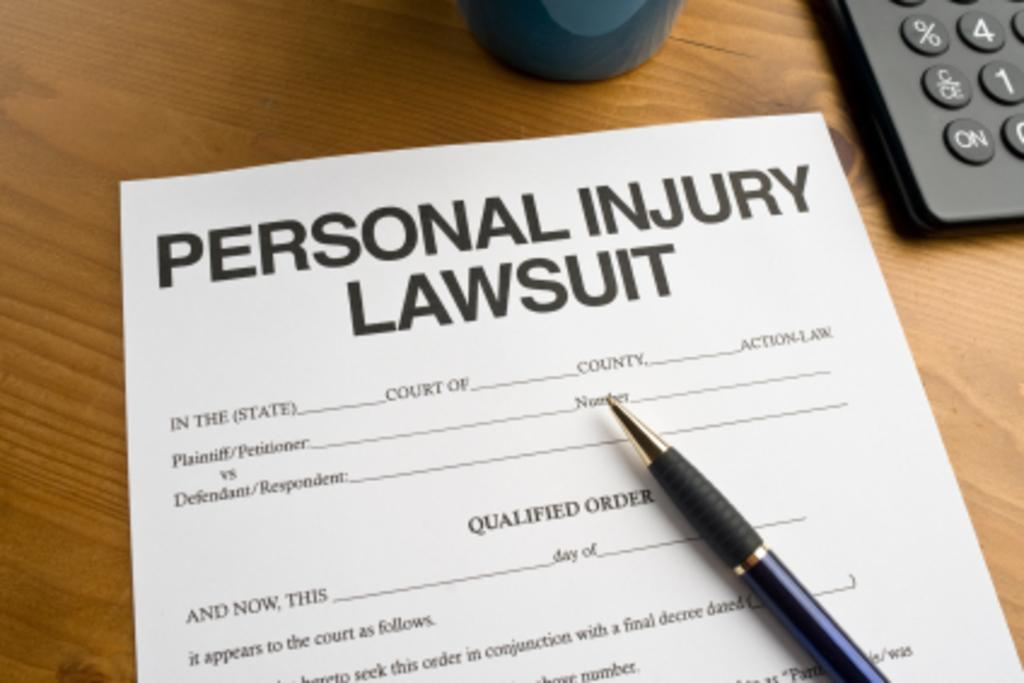<image>
Provide a brief description of the given image. A form that says Personal Injury Lawsuit is on a wooden desk by a pen, mug and remote. 